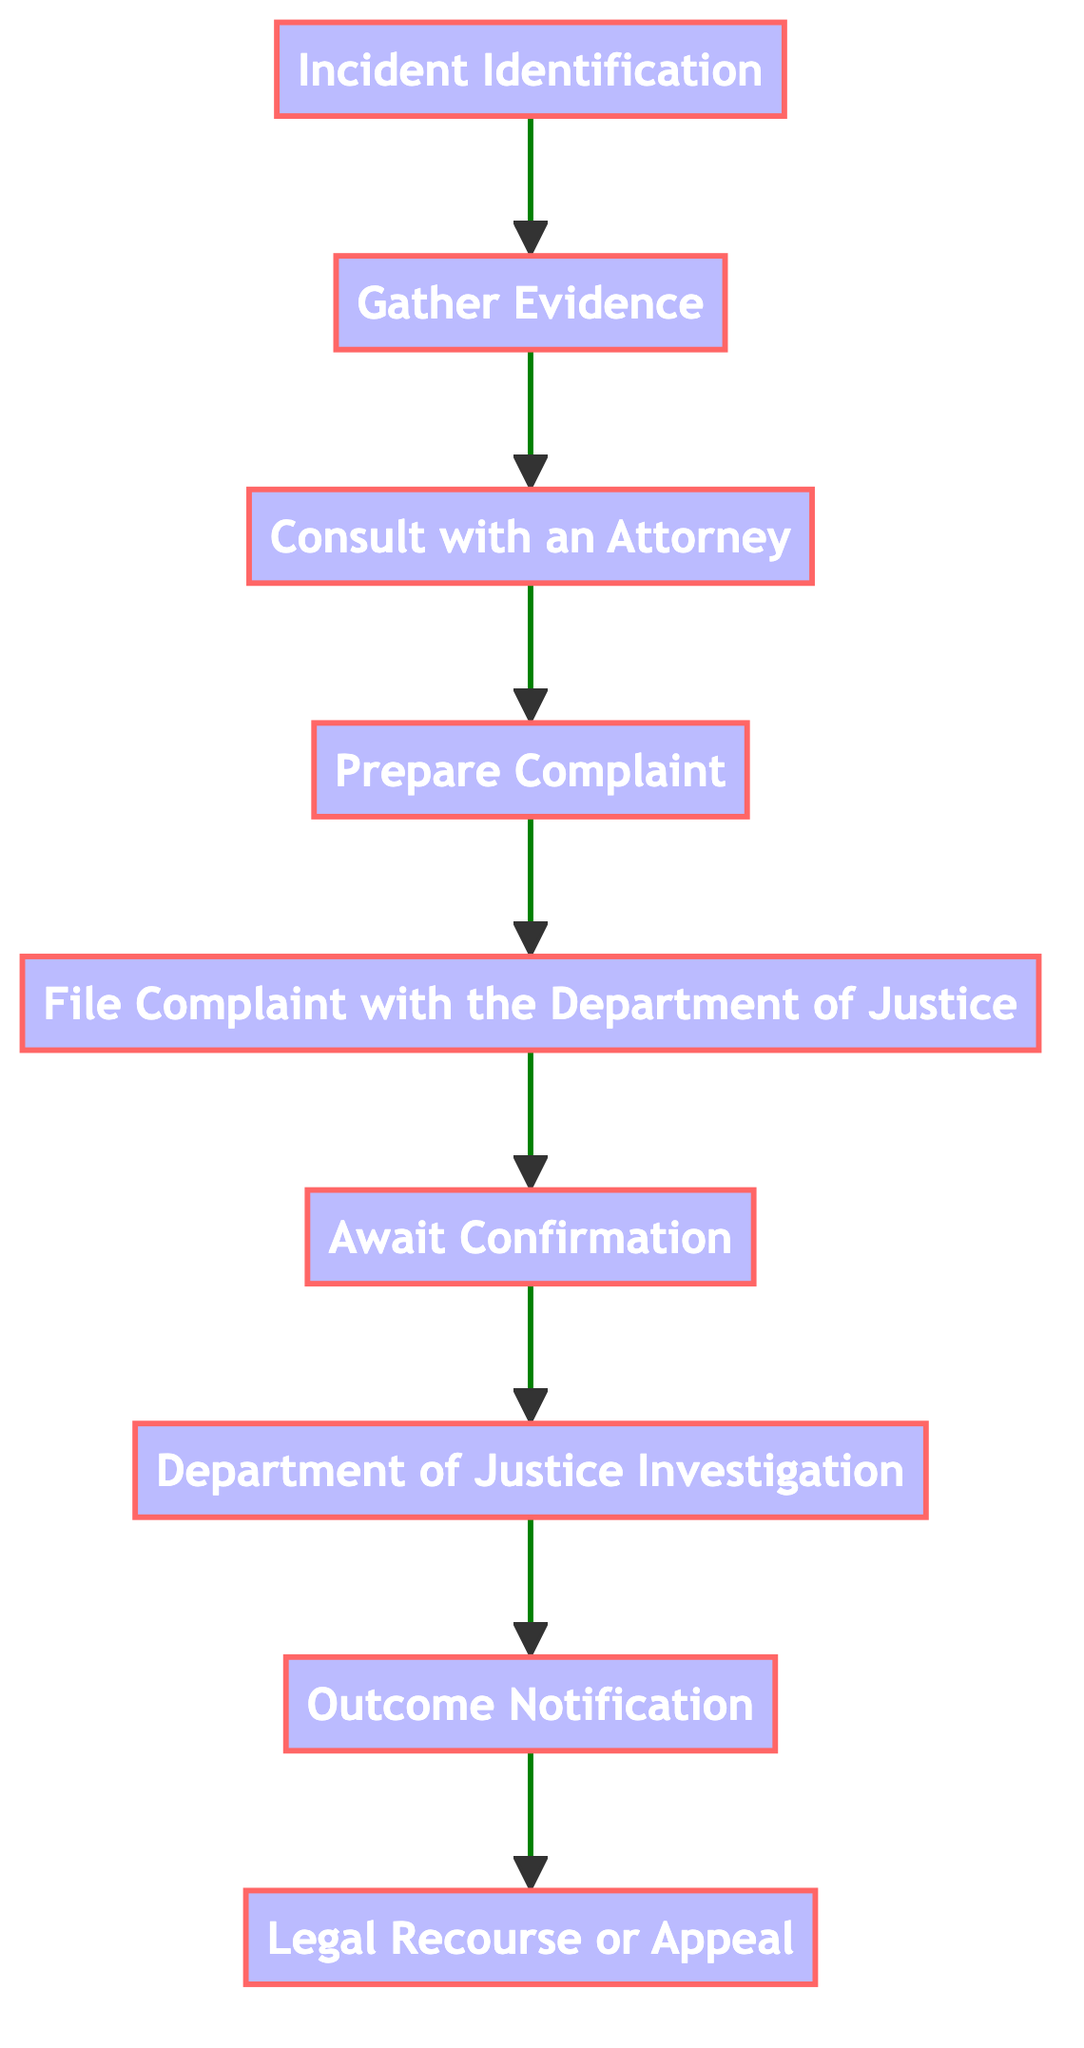What is the first step in the process? The first step in the process is identified as "Incident Identification," which is the initial action required before proceeding to the next steps.
Answer: Incident Identification How many steps are there in the entire process? Counting each identified step from the flowchart, there are a total of nine steps in the process outlined, from "Incident Identification" to "Legal Recourse or Appeal."
Answer: Nine What follows "Gather Evidence"? After "Gather Evidence," the next action in the process is "Consult with an Attorney," indicating the flow of tasks to be performed sequentially.
Answer: Consult with an Attorney What is the outcome of the "Department of Justice Investigation"? The outcome of the investigation is denoted as "Outcome Notification," which indicates that this is the next step following the investigation phase, leading to the final results of the process.
Answer: Outcome Notification What is the last step in the process? The last step in this flow chart is "Legal Recourse or Appeal," marking the conclusion of the outlined procedure for filing a civil rights complaint after a notification of the outcome.
Answer: Legal Recourse or Appeal Which step requires legal advice? "Consult with an Attorney" is the step where individuals are advised to seek legal counsel to better understand their rights and the strength of their case before proceeding with the complaint.
Answer: Consult with an Attorney How many nodes are there in the flowchart? The flowchart contains eight nodes that represent various steps in the process of filing a civil rights complaint against misconduct.
Answer: Eight Which steps involve waiting? The steps that involve a waiting period are "Await Confirmation," where one waits for acknowledgment of their complaint, and "Department of Justice Investigation," where the DOJ conducts its investigation, leading to a notification of the outcome.
Answer: Await Confirmation, Department of Justice Investigation What need is indicated before preparing the complaint? Before preparing the complaint, it is necessary to gather evidence, which lays the groundwork for drafting a well-informed formal complaint.
Answer: Gather Evidence 